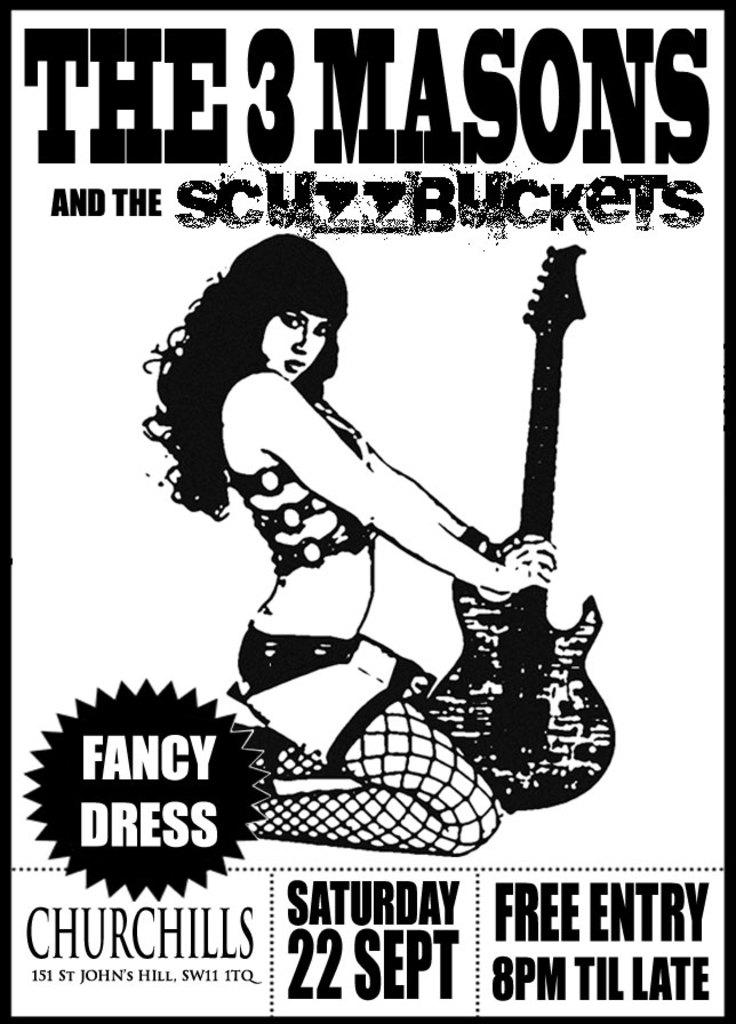<image>
Provide a brief description of the given image. A black and white poster has a picture of a scantily clad woman holding a guitar and advertises The # Mason and the Scuzzbuckets playing on Saturday, 22 Sept. 